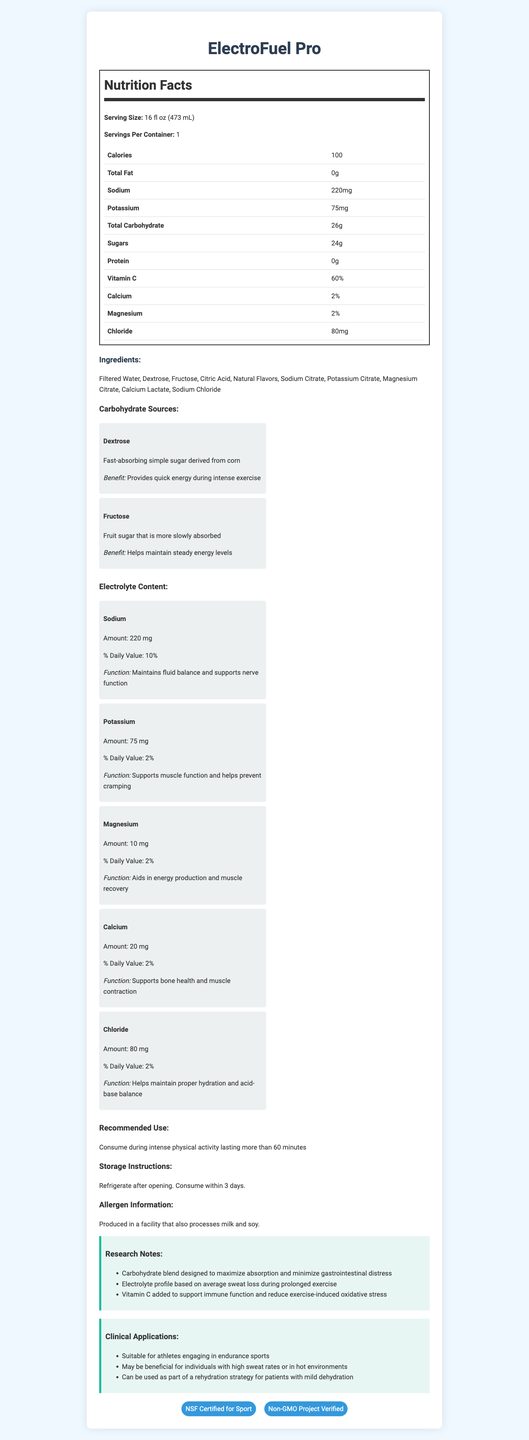What is the main carbohydrate source in ElectroFuel Pro? Dextrose is listed first in both the ingredients and the carbohydrate sources sections, indicating it is the main source.
Answer: Dextrose What is the serving size of ElectroFuel Pro? The serving size is clearly specified in the nutrition facts section.
Answer: 16 fl oz (473 mL) Which ingredient provides a quick energy boost during intense exercise? The description of dextrose states it provides quick energy during intense exercise.
Answer: Dextrose Explain the function of Sodium in ElectroFuel Pro. The electrolyte content section details the function of sodium.
Answer: Maintains fluid balance and supports nerve function What are the certifications held by ElectroFuel Pro? Both certifications are listed at the bottom of the document under the certifications section.
Answer: NSF Certified for Sport, Non-GMO Project Verified What is the main idea of the document? The document contains various sections including nutrition facts, ingredient list, carbohydrate sources, electrolyte content, recommended use, storage instructions, allergen information, research notes, clinical applications, and certifications, all related to ElectroFuel Pro.
Answer: The document provides detailed nutritional information, ingredients, and benefits of ElectroFuel Pro, a sports drink designed to provide quick energy and replenish electrolytes during intense physical activity. What is the recommended use for ElectroFuel Pro? The recommended use section explicitly states this.
Answer: Consume during intense physical activity lasting more than 60 minutes How much potassium is in one serving of ElectroFuel Pro? A. 50 mg B. 75 mg C. 100 mg D. 120 mg The electrolyte content and nutrition facts sections both state that there is 75 mg of potassium per serving.
Answer: B Why might an athlete choose ElectroFuel Pro? The carbohydrate sources and electrolyte content sections describe how the ingredients help maintain energy and electrolyte balance.
Answer: Provides quick energy and helps maintain electrolyte balance during intense exercise Is ElectroFuel Pro suitable for individuals engaging in endurance sports? The clinical applications section includes that ElectroFuel Pro is suitable for athletes engaging in endurance sports.
Answer: Yes What is the carbohydrate content per serving of ElectroFuel Pro? The nutrition facts section lists the total carbohydrate content as 26g per serving.
Answer: 26g Which ingredient helps maintain steady energy levels? I. Dextrose II. Fructose III. Citric Acid The description of fructose indicates it helps maintain steady energy levels, while dextrose provides quick energy and citric acid is not mentioned in this context.
Answer: II Can the protein content of ElectroFuel Pro be found in the document? The nutrition facts section lists the protein content as 0g.
Answer: Yes, it is 0g What is the electrolyte that helps in muscle recovery? The electrolyte content section specifies that magnesium aids in energy production and muscle recovery.
Answer: Magnesium Where is ElectroFuel Pro produced? The document does not specify the production location.
Answer: Not enough information List two reasons why Vitamin C is added to ElectroFuel Pro. The research notes section mentions that Vitamin C is added to support immune function and reduce exercise-induced oxidative stress.
Answer: Supports immune function and reduces exercise-induced oxidative stress 